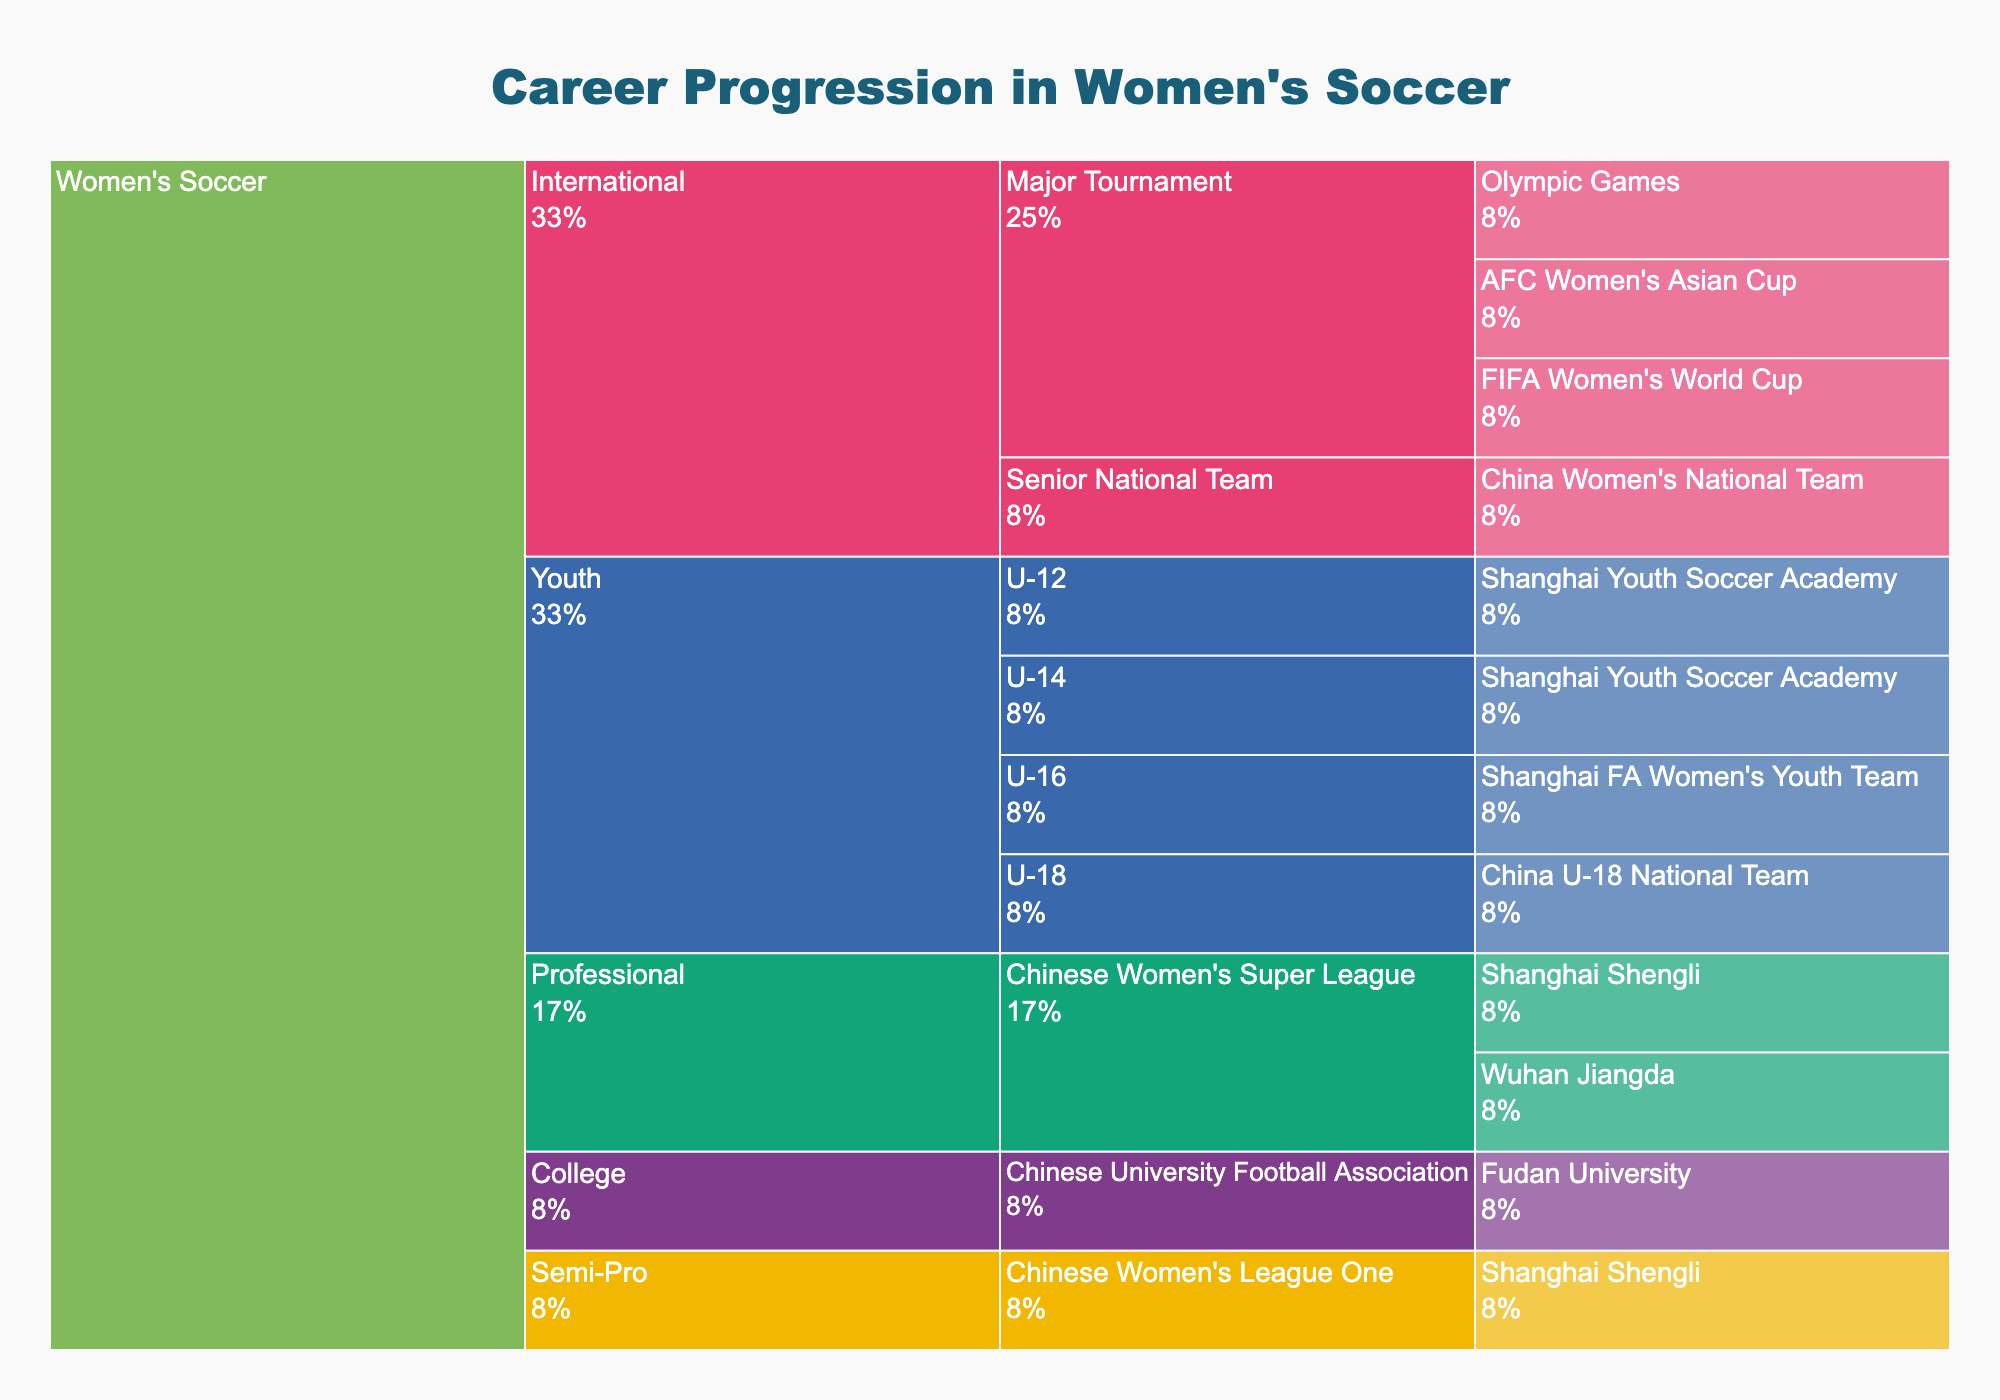What is the title of the figure? The title is typically displayed at the top center of the figure and is meant to give an overview of the chart's content. In this case, it should explain the icicle chart's focus.
Answer: Career Progression in Women's Soccer How many stages are there in the career progression? Stages are labeled within the hierarchy, starting from 'Career' down to 'Stage' as indicated by the icicle chart structure. Count the unique stages presented.
Answer: 5 Which team is associated with the U-12 Youth League? Locate the 'Youth' stage in the hierarchy, follow it down to the 'U-12' league, and identify the team at this level.
Answer: Shanghai Youth Soccer Academy At the professional stage, how many different teams are displayed? Navigate to the 'Professional' stage within the icicle chart and count the distinct teams listed under this category.
Answer: 2 Which league appears at both the semi-professional and professional stages? Examine the hierarchy for the 'Semi-Pro' and 'Professional' stages, and identify any league mentioned under both.
Answer: Chinese Women's Super League At the international stage, how many major tournaments are represented? Focus on the 'International' stage within the chart and count the unique entries listed under 'Major Tournament'.
Answer: 3 What paths lead to the 'China Women's National Team' at the international stage? Track the pathways starting from 'Career' down to the international stage, focusing specifically on the one that leads to the 'China Women's National Team'. List the stages.
Answer: Women's Soccer > International > Senior National Team > China Women's National Team Name the teams associated with the Shanghai Youth Soccer Academy. Look under the 'Youth' stage and identify the teams listed under the 'Shanghai Youth Soccer Academy' by locating the relevant leagues.
Answer: U-12, U-14 Which stage has the highest number of teams associated with it? Count the number of teams listed under each stage ('Youth,' 'College,' 'Semi-Pro,' 'Professional,' 'International'), and identify the stage with the most entries.
Answer: Youth 